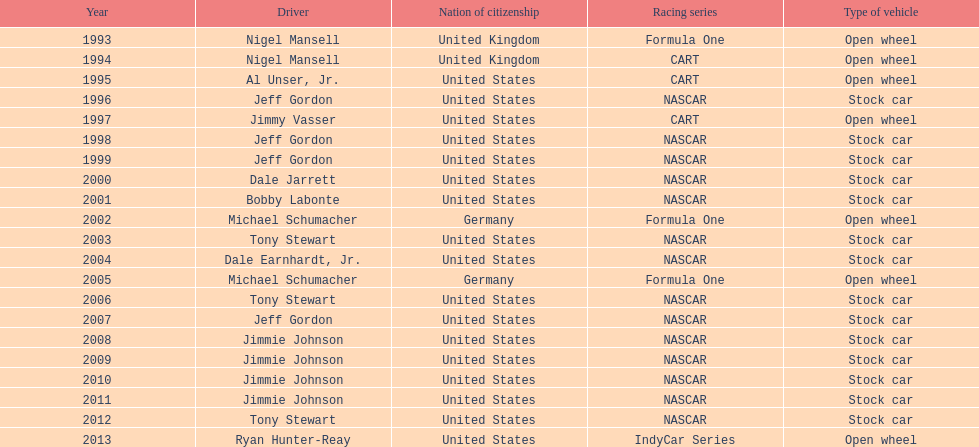Which driver managed to secure four wins in a row? Jimmie Johnson. 